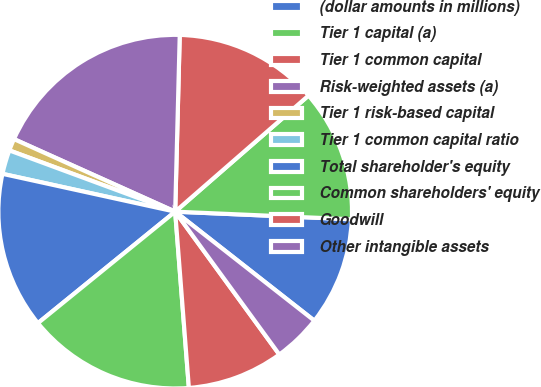Convert chart. <chart><loc_0><loc_0><loc_500><loc_500><pie_chart><fcel>(dollar amounts in millions)<fcel>Tier 1 capital (a)<fcel>Tier 1 common capital<fcel>Risk-weighted assets (a)<fcel>Tier 1 risk-based capital<fcel>Tier 1 common capital ratio<fcel>Total shareholder's equity<fcel>Common shareholders' equity<fcel>Goodwill<fcel>Other intangible assets<nl><fcel>9.89%<fcel>12.09%<fcel>13.19%<fcel>18.68%<fcel>1.1%<fcel>2.2%<fcel>14.29%<fcel>15.38%<fcel>8.79%<fcel>4.4%<nl></chart> 